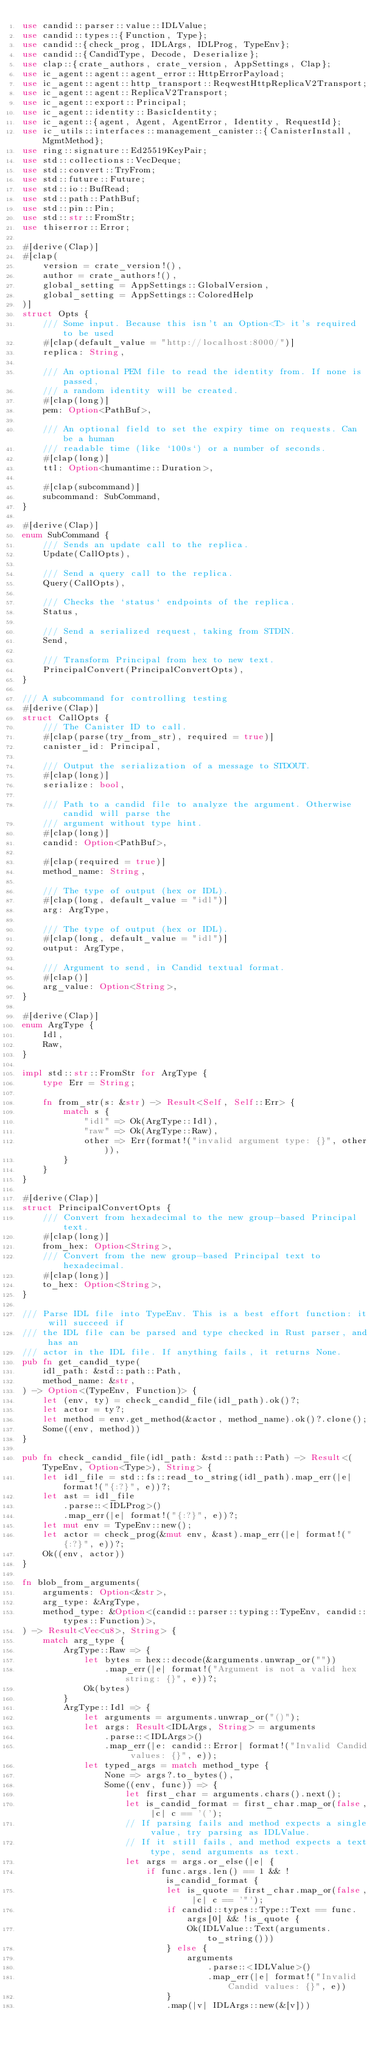<code> <loc_0><loc_0><loc_500><loc_500><_Rust_>use candid::parser::value::IDLValue;
use candid::types::{Function, Type};
use candid::{check_prog, IDLArgs, IDLProg, TypeEnv};
use candid::{CandidType, Decode, Deserialize};
use clap::{crate_authors, crate_version, AppSettings, Clap};
use ic_agent::agent::agent_error::HttpErrorPayload;
use ic_agent::agent::http_transport::ReqwestHttpReplicaV2Transport;
use ic_agent::agent::ReplicaV2Transport;
use ic_agent::export::Principal;
use ic_agent::identity::BasicIdentity;
use ic_agent::{agent, Agent, AgentError, Identity, RequestId};
use ic_utils::interfaces::management_canister::{CanisterInstall, MgmtMethod};
use ring::signature::Ed25519KeyPair;
use std::collections::VecDeque;
use std::convert::TryFrom;
use std::future::Future;
use std::io::BufRead;
use std::path::PathBuf;
use std::pin::Pin;
use std::str::FromStr;
use thiserror::Error;

#[derive(Clap)]
#[clap(
    version = crate_version!(),
    author = crate_authors!(),
    global_setting = AppSettings::GlobalVersion,
    global_setting = AppSettings::ColoredHelp
)]
struct Opts {
    /// Some input. Because this isn't an Option<T> it's required to be used
    #[clap(default_value = "http://localhost:8000/")]
    replica: String,

    /// An optional PEM file to read the identity from. If none is passed,
    /// a random identity will be created.
    #[clap(long)]
    pem: Option<PathBuf>,

    /// An optional field to set the expiry time on requests. Can be a human
    /// readable time (like `100s`) or a number of seconds.
    #[clap(long)]
    ttl: Option<humantime::Duration>,

    #[clap(subcommand)]
    subcommand: SubCommand,
}

#[derive(Clap)]
enum SubCommand {
    /// Sends an update call to the replica.
    Update(CallOpts),

    /// Send a query call to the replica.
    Query(CallOpts),

    /// Checks the `status` endpoints of the replica.
    Status,

    /// Send a serialized request, taking from STDIN.
    Send,

    /// Transform Principal from hex to new text.
    PrincipalConvert(PrincipalConvertOpts),
}

/// A subcommand for controlling testing
#[derive(Clap)]
struct CallOpts {
    /// The Canister ID to call.
    #[clap(parse(try_from_str), required = true)]
    canister_id: Principal,

    /// Output the serialization of a message to STDOUT.
    #[clap(long)]
    serialize: bool,

    /// Path to a candid file to analyze the argument. Otherwise candid will parse the
    /// argument without type hint.
    #[clap(long)]
    candid: Option<PathBuf>,

    #[clap(required = true)]
    method_name: String,

    /// The type of output (hex or IDL).
    #[clap(long, default_value = "idl")]
    arg: ArgType,

    /// The type of output (hex or IDL).
    #[clap(long, default_value = "idl")]
    output: ArgType,

    /// Argument to send, in Candid textual format.
    #[clap()]
    arg_value: Option<String>,
}

#[derive(Clap)]
enum ArgType {
    Idl,
    Raw,
}

impl std::str::FromStr for ArgType {
    type Err = String;

    fn from_str(s: &str) -> Result<Self, Self::Err> {
        match s {
            "idl" => Ok(ArgType::Idl),
            "raw" => Ok(ArgType::Raw),
            other => Err(format!("invalid argument type: {}", other)),
        }
    }
}

#[derive(Clap)]
struct PrincipalConvertOpts {
    /// Convert from hexadecimal to the new group-based Principal text.
    #[clap(long)]
    from_hex: Option<String>,
    /// Convert from the new group-based Principal text to hexadecimal.
    #[clap(long)]
    to_hex: Option<String>,
}

/// Parse IDL file into TypeEnv. This is a best effort function: it will succeed if
/// the IDL file can be parsed and type checked in Rust parser, and has an
/// actor in the IDL file. If anything fails, it returns None.
pub fn get_candid_type(
    idl_path: &std::path::Path,
    method_name: &str,
) -> Option<(TypeEnv, Function)> {
    let (env, ty) = check_candid_file(idl_path).ok()?;
    let actor = ty?;
    let method = env.get_method(&actor, method_name).ok()?.clone();
    Some((env, method))
}

pub fn check_candid_file(idl_path: &std::path::Path) -> Result<(TypeEnv, Option<Type>), String> {
    let idl_file = std::fs::read_to_string(idl_path).map_err(|e| format!("{:?}", e))?;
    let ast = idl_file
        .parse::<IDLProg>()
        .map_err(|e| format!("{:?}", e))?;
    let mut env = TypeEnv::new();
    let actor = check_prog(&mut env, &ast).map_err(|e| format!("{:?}", e))?;
    Ok((env, actor))
}

fn blob_from_arguments(
    arguments: Option<&str>,
    arg_type: &ArgType,
    method_type: &Option<(candid::parser::typing::TypeEnv, candid::types::Function)>,
) -> Result<Vec<u8>, String> {
    match arg_type {
        ArgType::Raw => {
            let bytes = hex::decode(&arguments.unwrap_or(""))
                .map_err(|e| format!("Argument is not a valid hex string: {}", e))?;
            Ok(bytes)
        }
        ArgType::Idl => {
            let arguments = arguments.unwrap_or("()");
            let args: Result<IDLArgs, String> = arguments
                .parse::<IDLArgs>()
                .map_err(|e: candid::Error| format!("Invalid Candid values: {}", e));
            let typed_args = match method_type {
                None => args?.to_bytes(),
                Some((env, func)) => {
                    let first_char = arguments.chars().next();
                    let is_candid_format = first_char.map_or(false, |c| c == '(');
                    // If parsing fails and method expects a single value, try parsing as IDLValue.
                    // If it still fails, and method expects a text type, send arguments as text.
                    let args = args.or_else(|e| {
                        if func.args.len() == 1 && !is_candid_format {
                            let is_quote = first_char.map_or(false, |c| c == '"');
                            if candid::types::Type::Text == func.args[0] && !is_quote {
                                Ok(IDLValue::Text(arguments.to_string()))
                            } else {
                                arguments
                                    .parse::<IDLValue>()
                                    .map_err(|e| format!("Invalid Candid values: {}", e))
                            }
                            .map(|v| IDLArgs::new(&[v]))</code> 